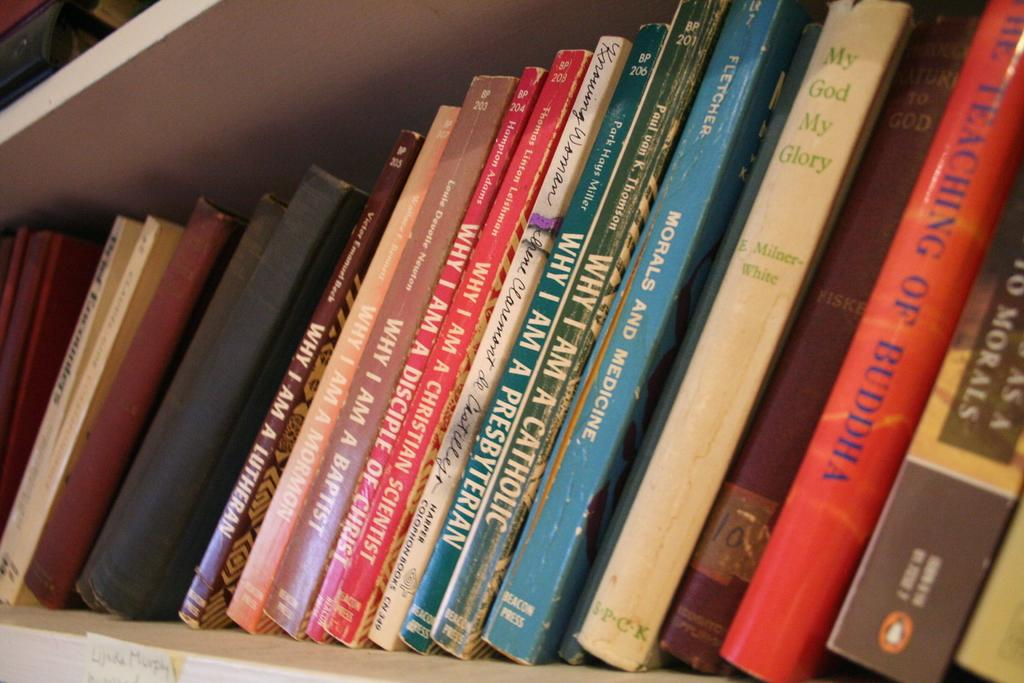<image>
Share a concise interpretation of the image provided. A red book among others that has the word Buddha written in blue lettering. 